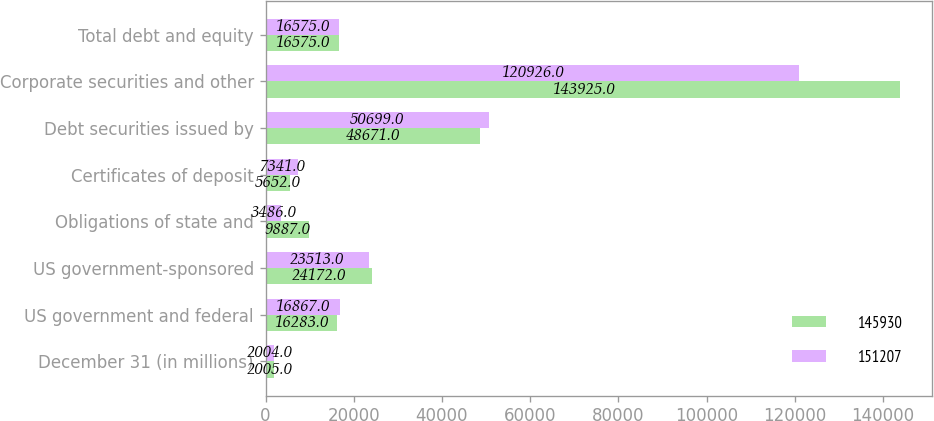<chart> <loc_0><loc_0><loc_500><loc_500><stacked_bar_chart><ecel><fcel>December 31 (in millions)<fcel>US government and federal<fcel>US government-sponsored<fcel>Obligations of state and<fcel>Certificates of deposit<fcel>Debt securities issued by<fcel>Corporate securities and other<fcel>Total debt and equity<nl><fcel>145930<fcel>2005<fcel>16283<fcel>24172<fcel>9887<fcel>5652<fcel>48671<fcel>143925<fcel>16575<nl><fcel>151207<fcel>2004<fcel>16867<fcel>23513<fcel>3486<fcel>7341<fcel>50699<fcel>120926<fcel>16575<nl></chart> 